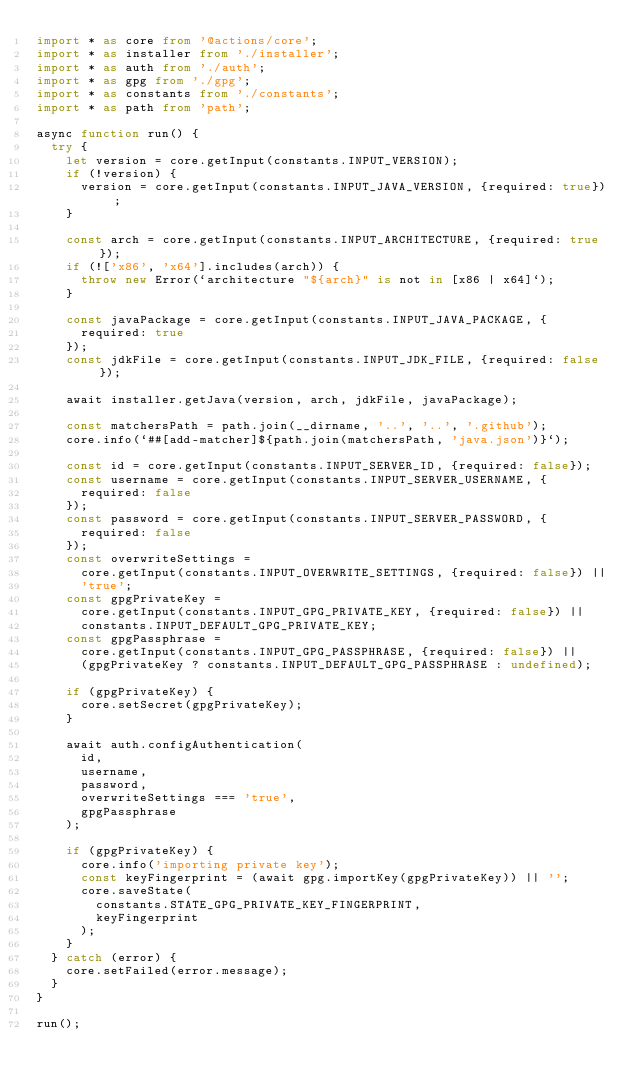<code> <loc_0><loc_0><loc_500><loc_500><_TypeScript_>import * as core from '@actions/core';
import * as installer from './installer';
import * as auth from './auth';
import * as gpg from './gpg';
import * as constants from './constants';
import * as path from 'path';

async function run() {
  try {
    let version = core.getInput(constants.INPUT_VERSION);
    if (!version) {
      version = core.getInput(constants.INPUT_JAVA_VERSION, {required: true});
    }

    const arch = core.getInput(constants.INPUT_ARCHITECTURE, {required: true});
    if (!['x86', 'x64'].includes(arch)) {
      throw new Error(`architecture "${arch}" is not in [x86 | x64]`);
    }

    const javaPackage = core.getInput(constants.INPUT_JAVA_PACKAGE, {
      required: true
    });
    const jdkFile = core.getInput(constants.INPUT_JDK_FILE, {required: false});

    await installer.getJava(version, arch, jdkFile, javaPackage);

    const matchersPath = path.join(__dirname, '..', '..', '.github');
    core.info(`##[add-matcher]${path.join(matchersPath, 'java.json')}`);

    const id = core.getInput(constants.INPUT_SERVER_ID, {required: false});
    const username = core.getInput(constants.INPUT_SERVER_USERNAME, {
      required: false
    });
    const password = core.getInput(constants.INPUT_SERVER_PASSWORD, {
      required: false
    });
    const overwriteSettings =
      core.getInput(constants.INPUT_OVERWRITE_SETTINGS, {required: false}) ||
      'true';
    const gpgPrivateKey =
      core.getInput(constants.INPUT_GPG_PRIVATE_KEY, {required: false}) ||
      constants.INPUT_DEFAULT_GPG_PRIVATE_KEY;
    const gpgPassphrase =
      core.getInput(constants.INPUT_GPG_PASSPHRASE, {required: false}) ||
      (gpgPrivateKey ? constants.INPUT_DEFAULT_GPG_PASSPHRASE : undefined);

    if (gpgPrivateKey) {
      core.setSecret(gpgPrivateKey);
    }

    await auth.configAuthentication(
      id,
      username,
      password,
      overwriteSettings === 'true',
      gpgPassphrase
    );

    if (gpgPrivateKey) {
      core.info('importing private key');
      const keyFingerprint = (await gpg.importKey(gpgPrivateKey)) || '';
      core.saveState(
        constants.STATE_GPG_PRIVATE_KEY_FINGERPRINT,
        keyFingerprint
      );
    }
  } catch (error) {
    core.setFailed(error.message);
  }
}

run();
</code> 